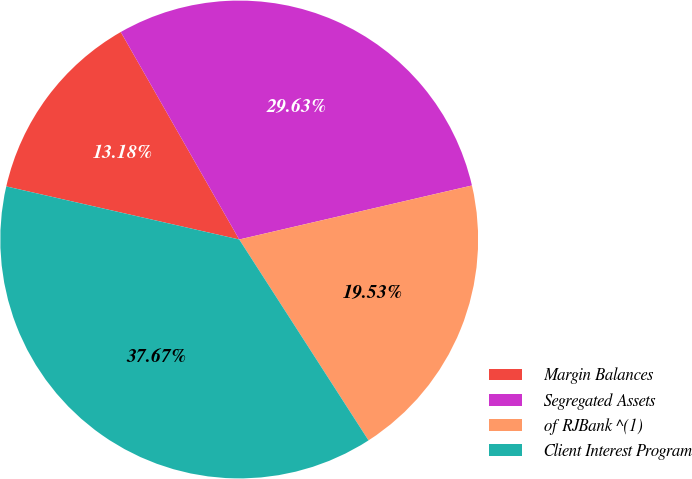Convert chart. <chart><loc_0><loc_0><loc_500><loc_500><pie_chart><fcel>Margin Balances<fcel>Segregated Assets<fcel>of RJBank ^(1)<fcel>Client Interest Program<nl><fcel>13.18%<fcel>29.63%<fcel>19.53%<fcel>37.67%<nl></chart> 